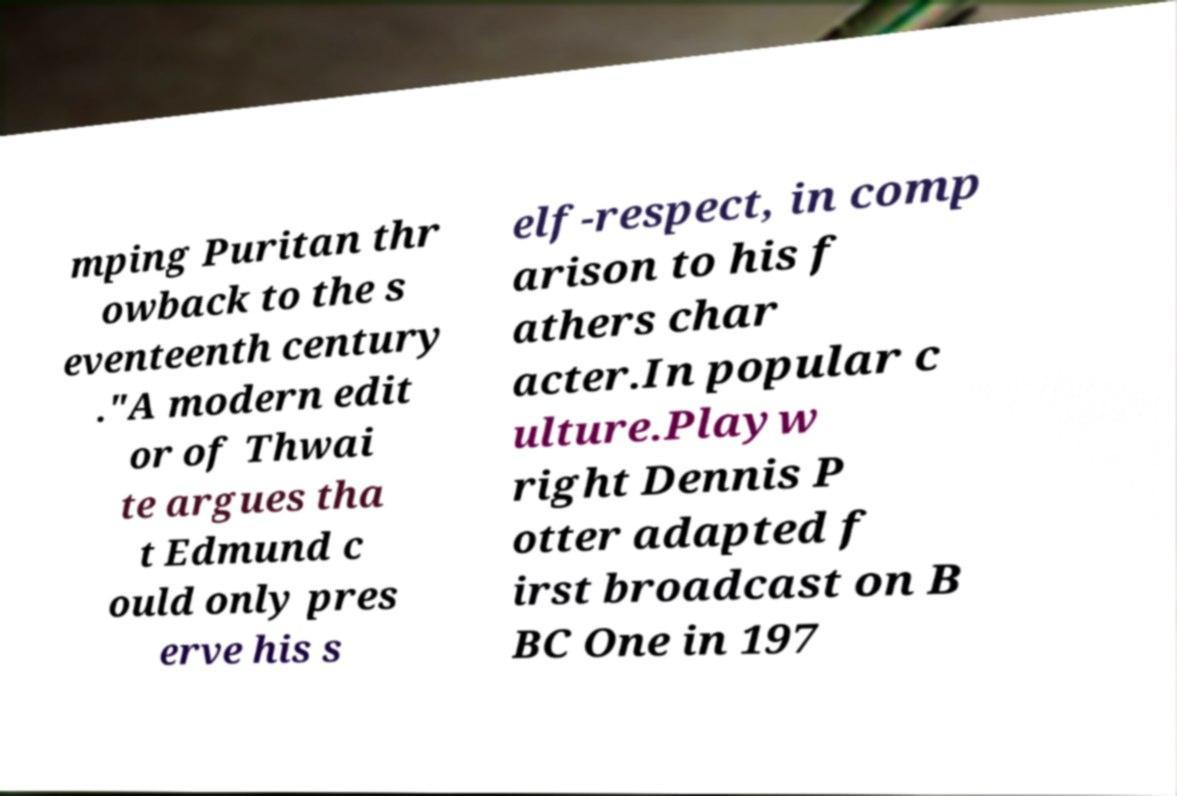Can you read and provide the text displayed in the image?This photo seems to have some interesting text. Can you extract and type it out for me? mping Puritan thr owback to the s eventeenth century ."A modern edit or of Thwai te argues tha t Edmund c ould only pres erve his s elf-respect, in comp arison to his f athers char acter.In popular c ulture.Playw right Dennis P otter adapted f irst broadcast on B BC One in 197 